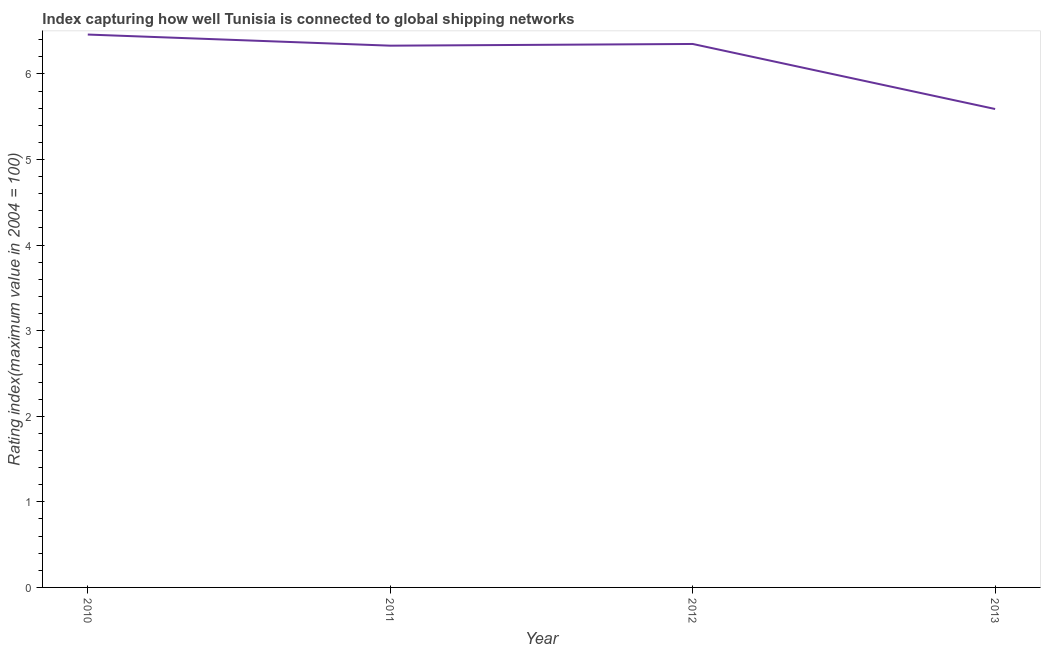What is the liner shipping connectivity index in 2011?
Give a very brief answer. 6.33. Across all years, what is the maximum liner shipping connectivity index?
Your response must be concise. 6.46. Across all years, what is the minimum liner shipping connectivity index?
Your answer should be very brief. 5.59. In which year was the liner shipping connectivity index maximum?
Your response must be concise. 2010. What is the sum of the liner shipping connectivity index?
Make the answer very short. 24.73. What is the difference between the liner shipping connectivity index in 2011 and 2012?
Keep it short and to the point. -0.02. What is the average liner shipping connectivity index per year?
Give a very brief answer. 6.18. What is the median liner shipping connectivity index?
Provide a succinct answer. 6.34. In how many years, is the liner shipping connectivity index greater than 1 ?
Your answer should be compact. 4. What is the ratio of the liner shipping connectivity index in 2011 to that in 2013?
Offer a terse response. 1.13. Is the liner shipping connectivity index in 2011 less than that in 2013?
Your response must be concise. No. What is the difference between the highest and the second highest liner shipping connectivity index?
Offer a terse response. 0.11. What is the difference between the highest and the lowest liner shipping connectivity index?
Give a very brief answer. 0.87. In how many years, is the liner shipping connectivity index greater than the average liner shipping connectivity index taken over all years?
Make the answer very short. 3. Does the liner shipping connectivity index monotonically increase over the years?
Your response must be concise. No. How many years are there in the graph?
Your answer should be compact. 4. Does the graph contain any zero values?
Your response must be concise. No. What is the title of the graph?
Your answer should be compact. Index capturing how well Tunisia is connected to global shipping networks. What is the label or title of the X-axis?
Make the answer very short. Year. What is the label or title of the Y-axis?
Your answer should be compact. Rating index(maximum value in 2004 = 100). What is the Rating index(maximum value in 2004 = 100) in 2010?
Make the answer very short. 6.46. What is the Rating index(maximum value in 2004 = 100) in 2011?
Offer a terse response. 6.33. What is the Rating index(maximum value in 2004 = 100) in 2012?
Give a very brief answer. 6.35. What is the Rating index(maximum value in 2004 = 100) of 2013?
Offer a very short reply. 5.59. What is the difference between the Rating index(maximum value in 2004 = 100) in 2010 and 2011?
Provide a short and direct response. 0.13. What is the difference between the Rating index(maximum value in 2004 = 100) in 2010 and 2012?
Offer a terse response. 0.11. What is the difference between the Rating index(maximum value in 2004 = 100) in 2010 and 2013?
Offer a terse response. 0.87. What is the difference between the Rating index(maximum value in 2004 = 100) in 2011 and 2012?
Keep it short and to the point. -0.02. What is the difference between the Rating index(maximum value in 2004 = 100) in 2011 and 2013?
Provide a short and direct response. 0.74. What is the difference between the Rating index(maximum value in 2004 = 100) in 2012 and 2013?
Your answer should be very brief. 0.76. What is the ratio of the Rating index(maximum value in 2004 = 100) in 2010 to that in 2013?
Provide a succinct answer. 1.16. What is the ratio of the Rating index(maximum value in 2004 = 100) in 2011 to that in 2012?
Your response must be concise. 1. What is the ratio of the Rating index(maximum value in 2004 = 100) in 2011 to that in 2013?
Provide a succinct answer. 1.13. What is the ratio of the Rating index(maximum value in 2004 = 100) in 2012 to that in 2013?
Offer a terse response. 1.14. 